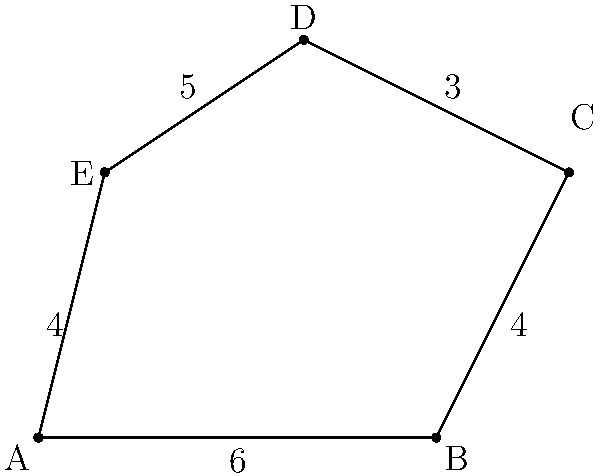As a software engineer, you're designing a custom-shaped garden for your partner who loves coding. The garden is represented by the irregular polygon ABCDE shown above. Given that the lengths of the sides are AB = 6 units, BC = 4 units, CD = 3 units, DE = 5 units, and EA = 4 units, calculate the perimeter of the garden. To calculate the perimeter of the irregular polygon ABCDE, we need to sum up the lengths of all its sides. Let's break it down step by step:

1. Identify the lengths of each side:
   - AB = 6 units
   - BC = 4 units
   - CD = 3 units
   - DE = 5 units
   - EA = 4 units

2. Set up the formula for perimeter:
   $$P = AB + BC + CD + DE + EA$$

3. Substitute the known values:
   $$P = 6 + 4 + 3 + 5 + 4$$

4. Perform the addition:
   $$P = 22$$

Therefore, the perimeter of the irregular polygon ABCDE (representing the garden) is 22 units.
Answer: 22 units 